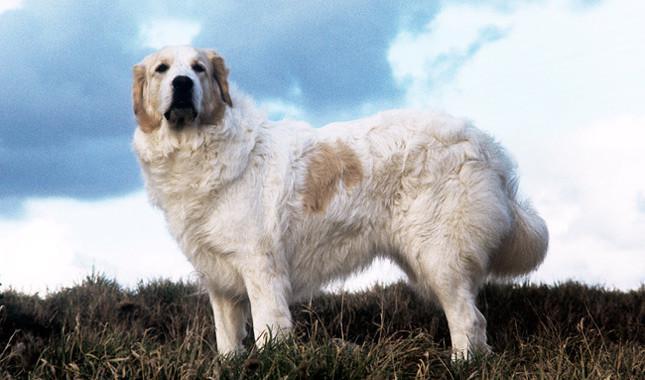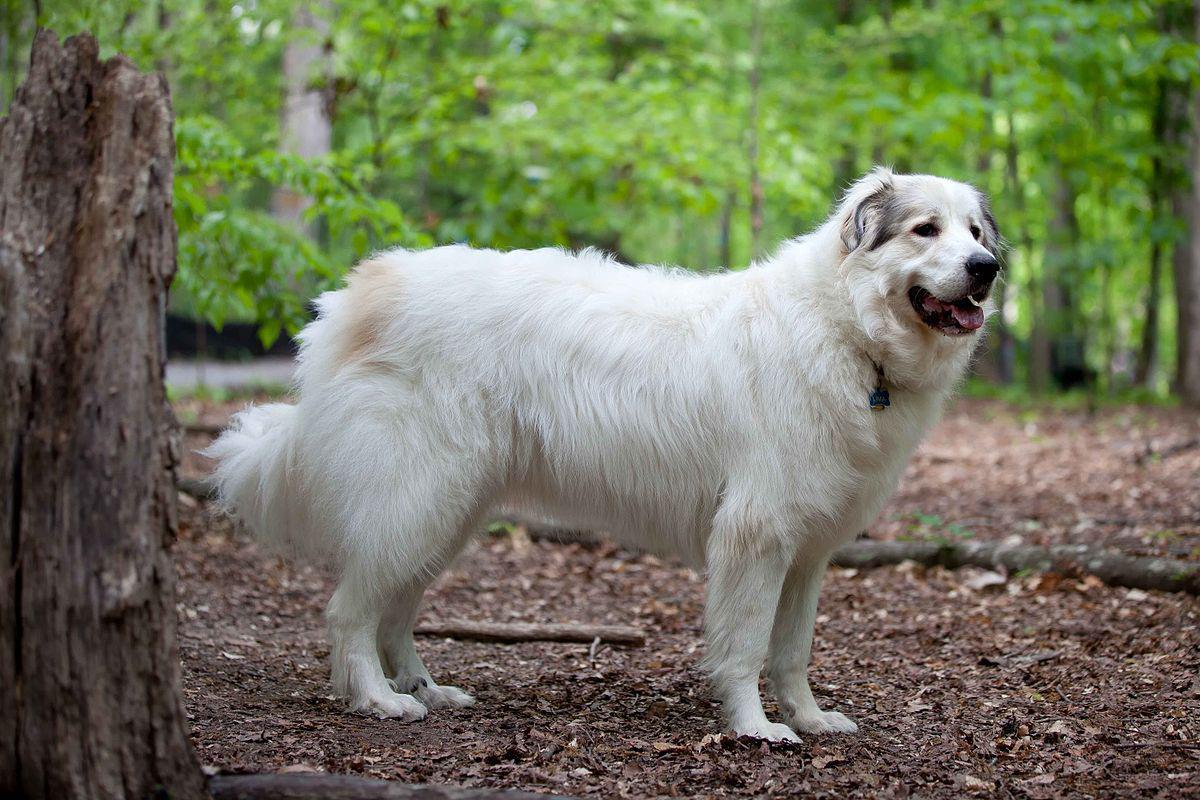The first image is the image on the left, the second image is the image on the right. Considering the images on both sides, is "There are no more than two white dogs." valid? Answer yes or no. Yes. The first image is the image on the left, the second image is the image on the right. Analyze the images presented: Is the assertion "At least one dog in an image in the pair has its mouth open and tongue visible." valid? Answer yes or no. Yes. The first image is the image on the left, the second image is the image on the right. Considering the images on both sides, is "There is a dog laying in the grass next to another dog" valid? Answer yes or no. No. The first image is the image on the left, the second image is the image on the right. Assess this claim about the two images: "There are two dogs". Correct or not? Answer yes or no. Yes. 